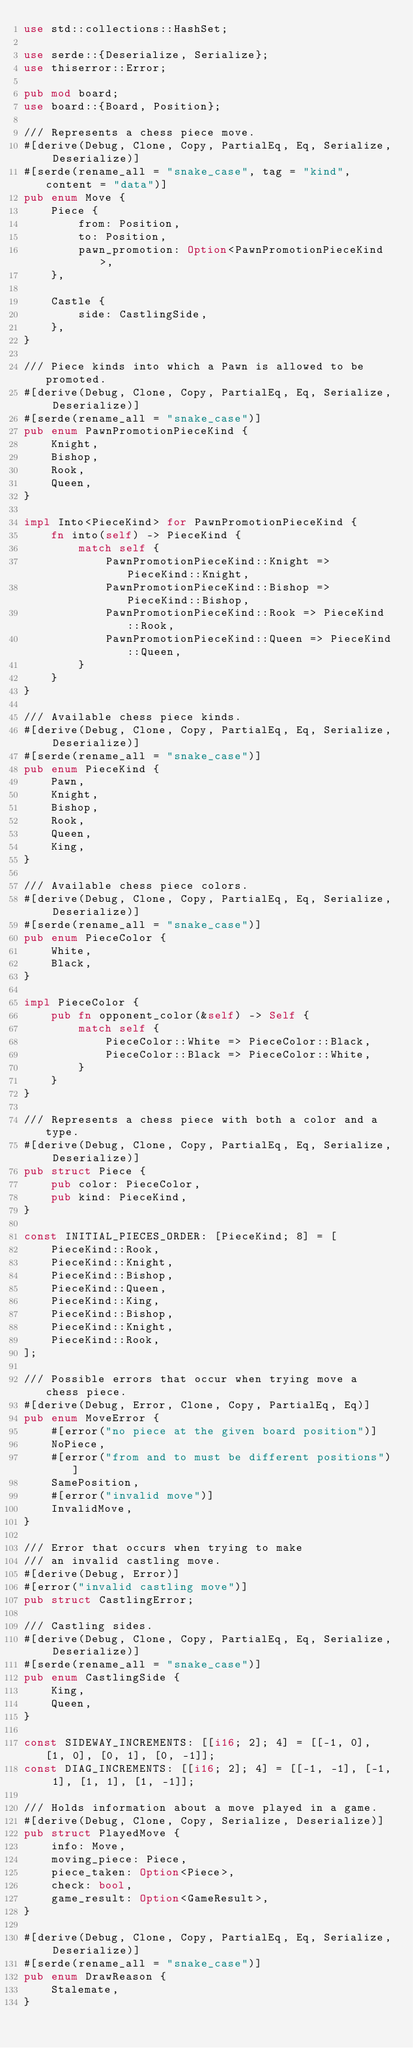Convert code to text. <code><loc_0><loc_0><loc_500><loc_500><_Rust_>use std::collections::HashSet;

use serde::{Deserialize, Serialize};
use thiserror::Error;

pub mod board;
use board::{Board, Position};

/// Represents a chess piece move.
#[derive(Debug, Clone, Copy, PartialEq, Eq, Serialize, Deserialize)]
#[serde(rename_all = "snake_case", tag = "kind", content = "data")]
pub enum Move {
    Piece {
        from: Position,
        to: Position,
        pawn_promotion: Option<PawnPromotionPieceKind>,
    },

    Castle {
        side: CastlingSide,
    },
}

/// Piece kinds into which a Pawn is allowed to be promoted.
#[derive(Debug, Clone, Copy, PartialEq, Eq, Serialize, Deserialize)]
#[serde(rename_all = "snake_case")]
pub enum PawnPromotionPieceKind {
    Knight,
    Bishop,
    Rook,
    Queen,
}

impl Into<PieceKind> for PawnPromotionPieceKind {
    fn into(self) -> PieceKind {
        match self {
            PawnPromotionPieceKind::Knight => PieceKind::Knight,
            PawnPromotionPieceKind::Bishop => PieceKind::Bishop,
            PawnPromotionPieceKind::Rook => PieceKind::Rook,
            PawnPromotionPieceKind::Queen => PieceKind::Queen,
        }
    }
}

/// Available chess piece kinds.
#[derive(Debug, Clone, Copy, PartialEq, Eq, Serialize, Deserialize)]
#[serde(rename_all = "snake_case")]
pub enum PieceKind {
    Pawn,
    Knight,
    Bishop,
    Rook,
    Queen,
    King,
}

/// Available chess piece colors.
#[derive(Debug, Clone, Copy, PartialEq, Eq, Serialize, Deserialize)]
#[serde(rename_all = "snake_case")]
pub enum PieceColor {
    White,
    Black,
}

impl PieceColor {
    pub fn opponent_color(&self) -> Self {
        match self {
            PieceColor::White => PieceColor::Black,
            PieceColor::Black => PieceColor::White,
        }
    }
}

/// Represents a chess piece with both a color and a type.
#[derive(Debug, Clone, Copy, PartialEq, Eq, Serialize, Deserialize)]
pub struct Piece {
    pub color: PieceColor,
    pub kind: PieceKind,
}

const INITIAL_PIECES_ORDER: [PieceKind; 8] = [
    PieceKind::Rook,
    PieceKind::Knight,
    PieceKind::Bishop,
    PieceKind::Queen,
    PieceKind::King,
    PieceKind::Bishop,
    PieceKind::Knight,
    PieceKind::Rook,
];

/// Possible errors that occur when trying move a chess piece.
#[derive(Debug, Error, Clone, Copy, PartialEq, Eq)]
pub enum MoveError {
    #[error("no piece at the given board position")]
    NoPiece,
    #[error("from and to must be different positions")]
    SamePosition,
    #[error("invalid move")]
    InvalidMove,
}

/// Error that occurs when trying to make
/// an invalid castling move.
#[derive(Debug, Error)]
#[error("invalid castling move")]
pub struct CastlingError;

/// Castling sides.
#[derive(Debug, Clone, Copy, PartialEq, Eq, Serialize, Deserialize)]
#[serde(rename_all = "snake_case")]
pub enum CastlingSide {
    King,
    Queen,
}

const SIDEWAY_INCREMENTS: [[i16; 2]; 4] = [[-1, 0], [1, 0], [0, 1], [0, -1]];
const DIAG_INCREMENTS: [[i16; 2]; 4] = [[-1, -1], [-1, 1], [1, 1], [1, -1]];

/// Holds information about a move played in a game.
#[derive(Debug, Clone, Copy, Serialize, Deserialize)]
pub struct PlayedMove {
    info: Move,
    moving_piece: Piece,
    piece_taken: Option<Piece>,
    check: bool,
    game_result: Option<GameResult>,
}

#[derive(Debug, Clone, Copy, PartialEq, Eq, Serialize, Deserialize)]
#[serde(rename_all = "snake_case")]
pub enum DrawReason {
    Stalemate,
}
</code> 